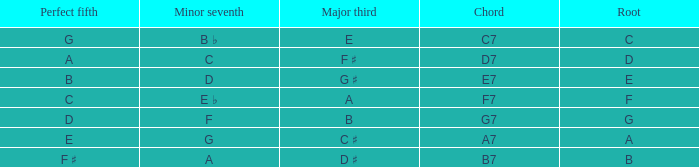What is the Chord with a Minor that is seventh of f? G7. 